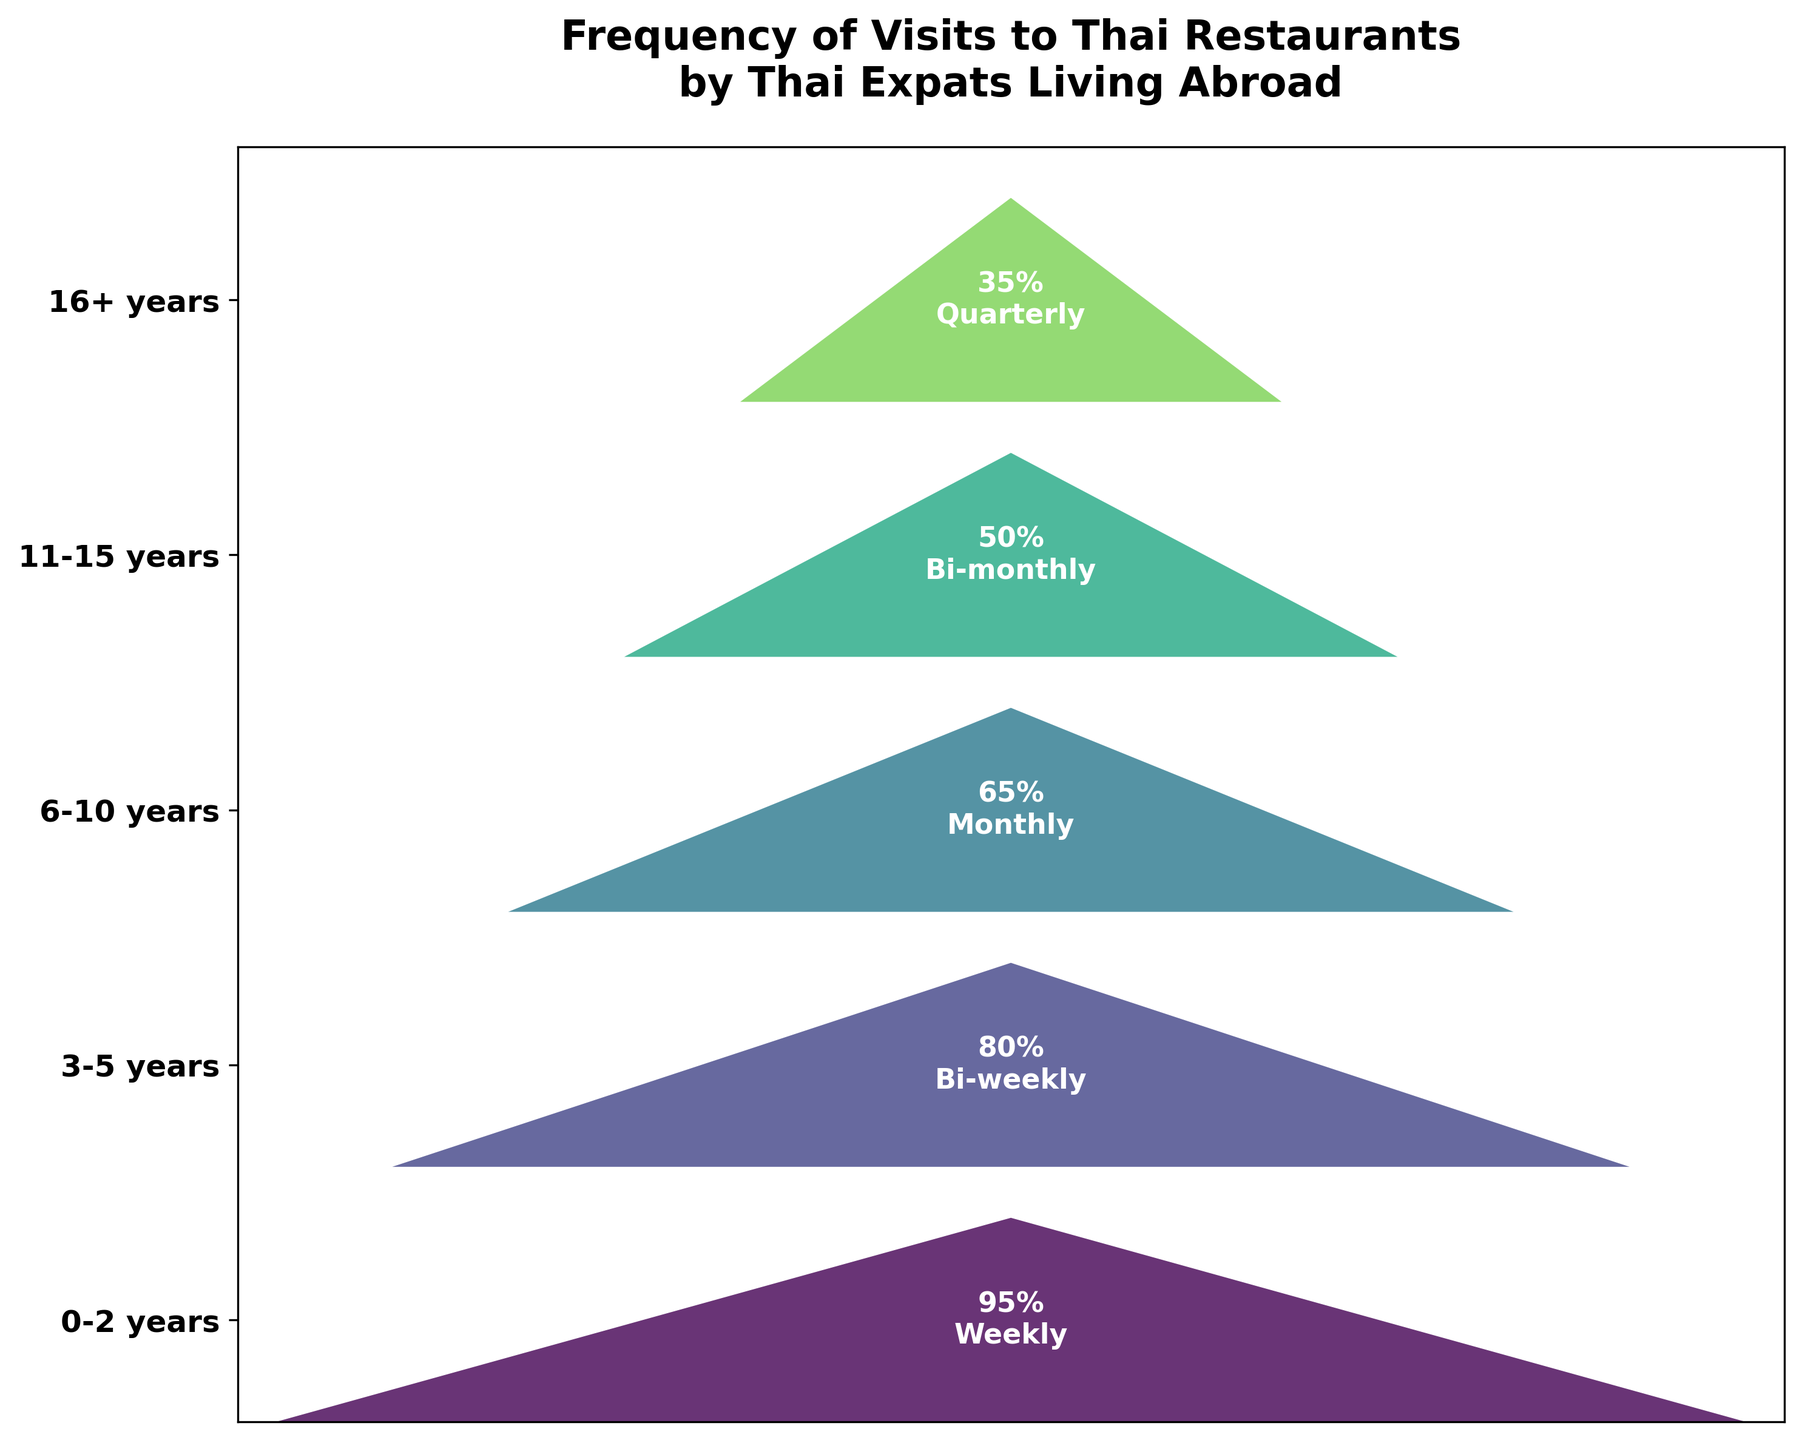What is the percentage of Thai expats who visit Thai restaurants weekly? The funnel chart shows that the frequency of visits for Thai expats who have lived abroad for 0-2 years is weekly. The associated percentage is labeled on the plot directly.
Answer: 95% How does the frequency of visits change for Thai expats who have lived abroad for 6-10 years compared to those who have lived abroad for 11-15 years? The chart indicates that for 6-10 years, the visit frequency is monthly, with 65% visiting Thai restaurants, whereas for 11-15 years, the frequency is bi-monthly, with 50% visiting. The frequency lowers and the percentage decreases.
Answer: Monthly to bi-monthly; 65% to 50% Which group of Thai expats has the lowest percentage of visits? By examining the funnel chart, it's clear that the group with the longest time living abroad, 16+ years, has the lowest percentage of visits, which is 35%.
Answer: 16+ years What is the difference in percentage between Thai expats who visit Thai restaurants quarterly and those who visit bi-weekly? The group visiting quarterly (16+ years) has a percentage of 35%, while those visiting bi-weekly (3-5 years) have 80%. The difference can be calculated as 80% - 35%.
Answer: 45% List the visit frequencies in decreasing order of the percentage of Thai expats. Reading from the chart from top to bottom based on the funnel width and annotated percentages, the order is: Weekly (95%), Bi-weekly (80%), Monthly (65%), Bi-monthly (50%), and Quarterly (35%).
Answer: Weekly, Bi-weekly, Monthly, Bi-monthly, Quarterly Estimate the median frequency of Thai expats' visits to Thai restaurants based on the chart data. There are five frequency categories: Weekly, Bi-weekly, Monthly, Bi-monthly, and Quarterly. The middle one, when ordered by percentages (95%, 80%, 65%, 50%, 35%), is Monthly (65%).
Answer: Monthly Is there an equal percentage change from one group to the next in the chart? The differences between consecutive categories can be computed: 95% to 80% (15%), 80% to 65% (15%), 65% to 50% (15%), 50% to 35% (15%). This shows the percentage change between each group is consistent at 15%, indicating equal change.
Answer: Yes, 15% Which period sees a drop to bi-monthly visits? From the funnel chart, the shift to bi-monthly visits occurs in the group of Thai expats who have lived abroad for 11-15 years.
Answer: 11-15 years 